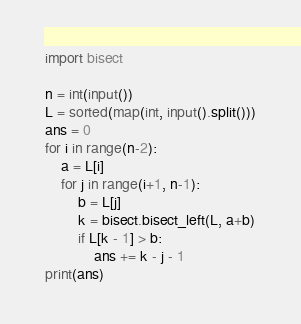<code> <loc_0><loc_0><loc_500><loc_500><_Python_>import bisect

n = int(input())
L = sorted(map(int, input().split()))
ans = 0
for i in range(n-2):
    a = L[i]
    for j in range(i+1, n-1):
        b = L[j]
        k = bisect.bisect_left(L, a+b)
        if L[k - 1] > b:
            ans += k - j - 1
print(ans)
</code> 